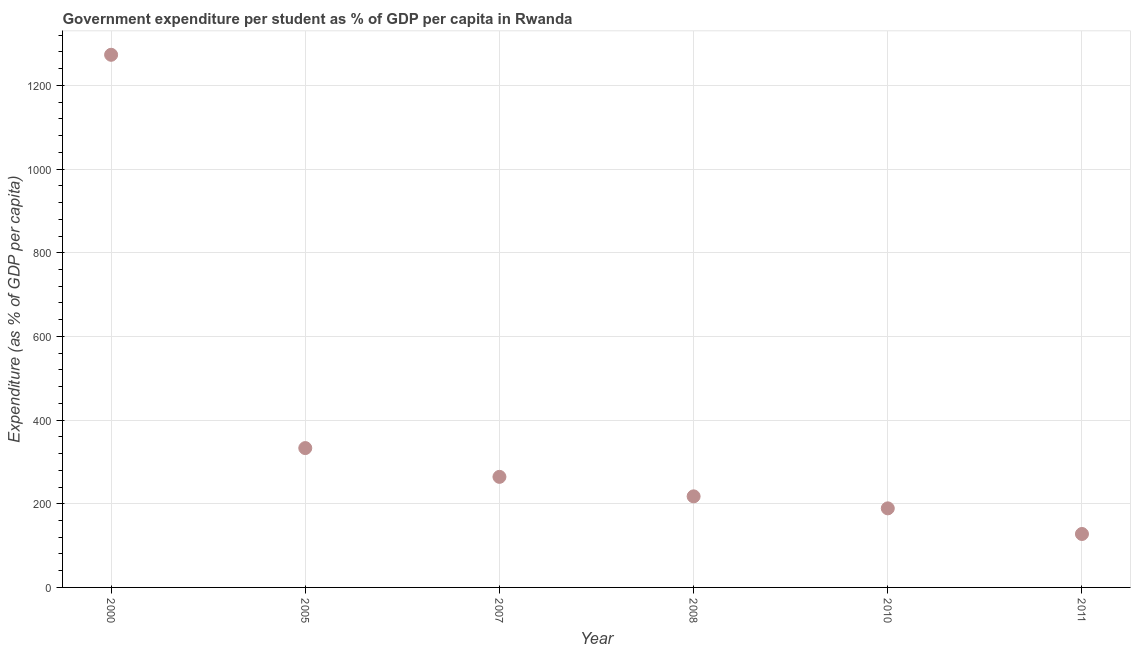What is the government expenditure per student in 2005?
Keep it short and to the point. 333.07. Across all years, what is the maximum government expenditure per student?
Provide a short and direct response. 1273.22. Across all years, what is the minimum government expenditure per student?
Make the answer very short. 127.75. In which year was the government expenditure per student maximum?
Offer a terse response. 2000. In which year was the government expenditure per student minimum?
Offer a very short reply. 2011. What is the sum of the government expenditure per student?
Your answer should be very brief. 2405.06. What is the difference between the government expenditure per student in 2000 and 2008?
Your answer should be very brief. 1055.52. What is the average government expenditure per student per year?
Your answer should be compact. 400.84. What is the median government expenditure per student?
Give a very brief answer. 241. In how many years, is the government expenditure per student greater than 200 %?
Offer a terse response. 4. What is the ratio of the government expenditure per student in 2005 to that in 2008?
Your response must be concise. 1.53. Is the difference between the government expenditure per student in 2007 and 2011 greater than the difference between any two years?
Provide a succinct answer. No. What is the difference between the highest and the second highest government expenditure per student?
Your response must be concise. 940.15. What is the difference between the highest and the lowest government expenditure per student?
Offer a terse response. 1145.47. In how many years, is the government expenditure per student greater than the average government expenditure per student taken over all years?
Provide a short and direct response. 1. Does the government expenditure per student monotonically increase over the years?
Keep it short and to the point. No. How many dotlines are there?
Ensure brevity in your answer.  1. How many years are there in the graph?
Your answer should be compact. 6. What is the difference between two consecutive major ticks on the Y-axis?
Keep it short and to the point. 200. Are the values on the major ticks of Y-axis written in scientific E-notation?
Offer a very short reply. No. Does the graph contain any zero values?
Your answer should be compact. No. What is the title of the graph?
Offer a very short reply. Government expenditure per student as % of GDP per capita in Rwanda. What is the label or title of the Y-axis?
Ensure brevity in your answer.  Expenditure (as % of GDP per capita). What is the Expenditure (as % of GDP per capita) in 2000?
Your answer should be compact. 1273.22. What is the Expenditure (as % of GDP per capita) in 2005?
Provide a succinct answer. 333.07. What is the Expenditure (as % of GDP per capita) in 2007?
Offer a terse response. 264.3. What is the Expenditure (as % of GDP per capita) in 2008?
Offer a terse response. 217.7. What is the Expenditure (as % of GDP per capita) in 2010?
Make the answer very short. 189.02. What is the Expenditure (as % of GDP per capita) in 2011?
Keep it short and to the point. 127.75. What is the difference between the Expenditure (as % of GDP per capita) in 2000 and 2005?
Make the answer very short. 940.15. What is the difference between the Expenditure (as % of GDP per capita) in 2000 and 2007?
Your response must be concise. 1008.92. What is the difference between the Expenditure (as % of GDP per capita) in 2000 and 2008?
Your answer should be compact. 1055.52. What is the difference between the Expenditure (as % of GDP per capita) in 2000 and 2010?
Offer a very short reply. 1084.2. What is the difference between the Expenditure (as % of GDP per capita) in 2000 and 2011?
Offer a terse response. 1145.47. What is the difference between the Expenditure (as % of GDP per capita) in 2005 and 2007?
Provide a short and direct response. 68.77. What is the difference between the Expenditure (as % of GDP per capita) in 2005 and 2008?
Keep it short and to the point. 115.37. What is the difference between the Expenditure (as % of GDP per capita) in 2005 and 2010?
Give a very brief answer. 144.05. What is the difference between the Expenditure (as % of GDP per capita) in 2005 and 2011?
Your answer should be compact. 205.32. What is the difference between the Expenditure (as % of GDP per capita) in 2007 and 2008?
Provide a short and direct response. 46.6. What is the difference between the Expenditure (as % of GDP per capita) in 2007 and 2010?
Provide a succinct answer. 75.28. What is the difference between the Expenditure (as % of GDP per capita) in 2007 and 2011?
Keep it short and to the point. 136.55. What is the difference between the Expenditure (as % of GDP per capita) in 2008 and 2010?
Give a very brief answer. 28.68. What is the difference between the Expenditure (as % of GDP per capita) in 2008 and 2011?
Give a very brief answer. 89.95. What is the difference between the Expenditure (as % of GDP per capita) in 2010 and 2011?
Offer a terse response. 61.27. What is the ratio of the Expenditure (as % of GDP per capita) in 2000 to that in 2005?
Make the answer very short. 3.82. What is the ratio of the Expenditure (as % of GDP per capita) in 2000 to that in 2007?
Provide a short and direct response. 4.82. What is the ratio of the Expenditure (as % of GDP per capita) in 2000 to that in 2008?
Your answer should be very brief. 5.85. What is the ratio of the Expenditure (as % of GDP per capita) in 2000 to that in 2010?
Give a very brief answer. 6.74. What is the ratio of the Expenditure (as % of GDP per capita) in 2000 to that in 2011?
Provide a short and direct response. 9.97. What is the ratio of the Expenditure (as % of GDP per capita) in 2005 to that in 2007?
Your answer should be compact. 1.26. What is the ratio of the Expenditure (as % of GDP per capita) in 2005 to that in 2008?
Your response must be concise. 1.53. What is the ratio of the Expenditure (as % of GDP per capita) in 2005 to that in 2010?
Provide a succinct answer. 1.76. What is the ratio of the Expenditure (as % of GDP per capita) in 2005 to that in 2011?
Ensure brevity in your answer.  2.61. What is the ratio of the Expenditure (as % of GDP per capita) in 2007 to that in 2008?
Provide a succinct answer. 1.21. What is the ratio of the Expenditure (as % of GDP per capita) in 2007 to that in 2010?
Offer a terse response. 1.4. What is the ratio of the Expenditure (as % of GDP per capita) in 2007 to that in 2011?
Keep it short and to the point. 2.07. What is the ratio of the Expenditure (as % of GDP per capita) in 2008 to that in 2010?
Keep it short and to the point. 1.15. What is the ratio of the Expenditure (as % of GDP per capita) in 2008 to that in 2011?
Your answer should be compact. 1.7. What is the ratio of the Expenditure (as % of GDP per capita) in 2010 to that in 2011?
Keep it short and to the point. 1.48. 